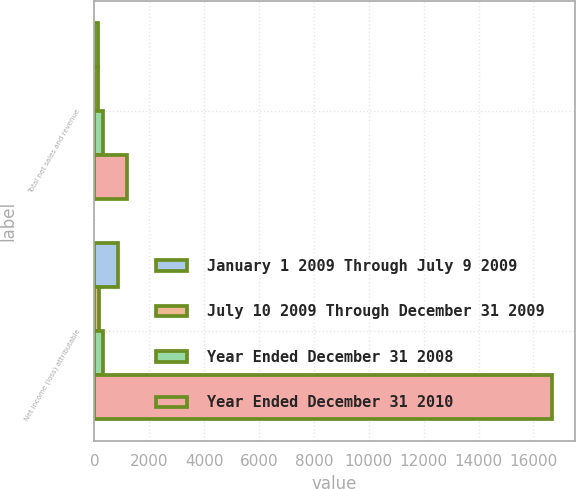Convert chart to OTSL. <chart><loc_0><loc_0><loc_500><loc_500><stacked_bar_chart><ecel><fcel>Total net sales and revenue<fcel>Net income (loss) attributable<nl><fcel>January 1 2009 Through July 9 2009<fcel>134<fcel>877<nl><fcel>July 10 2009 Through December 31 2009<fcel>141<fcel>176<nl><fcel>Year Ended December 31 2008<fcel>327<fcel>327<nl><fcel>Year Ended December 31 2010<fcel>1206<fcel>16677<nl></chart> 